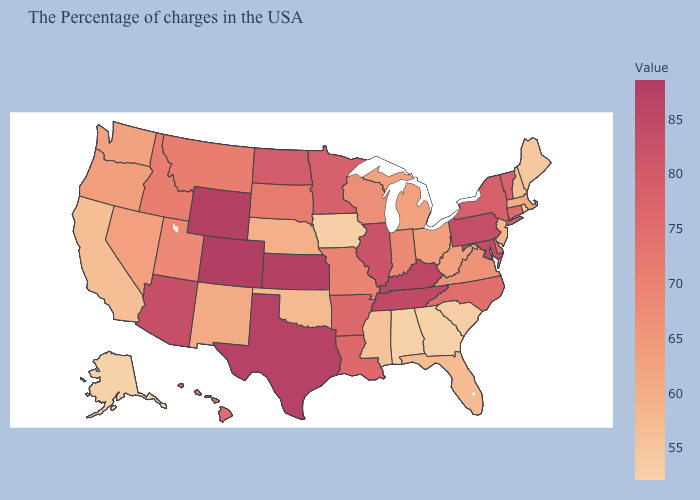Does Alaska have the lowest value in the USA?
Write a very short answer. Yes. Among the states that border New York , which have the highest value?
Write a very short answer. Pennsylvania. Does Kansas have the highest value in the MidWest?
Give a very brief answer. Yes. Among the states that border New York , does Pennsylvania have the lowest value?
Answer briefly. No. Does Wyoming have the highest value in the USA?
Concise answer only. No. Does Tennessee have the highest value in the USA?
Be succinct. No. 